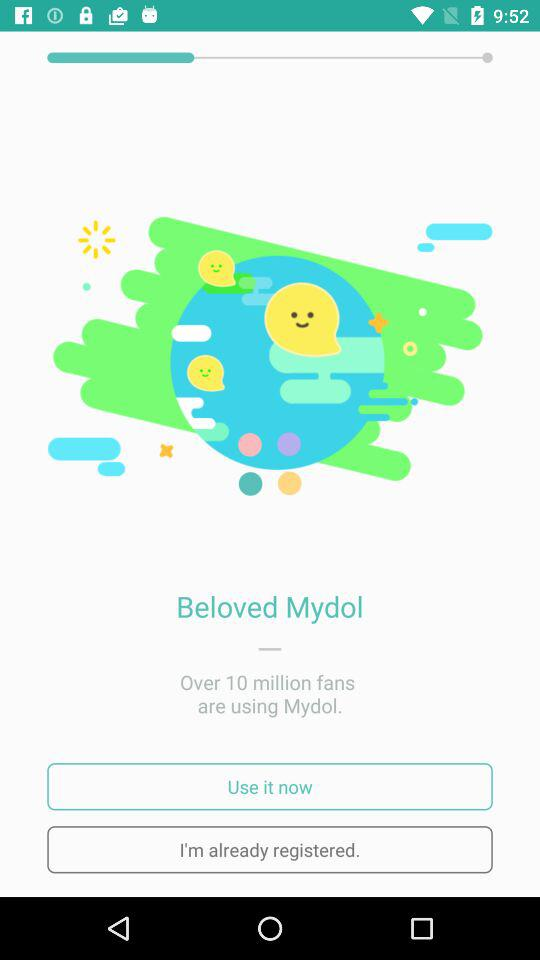How many fans are using the "Mydol" application? There are over 10 million fans using the "Mydol" application. 